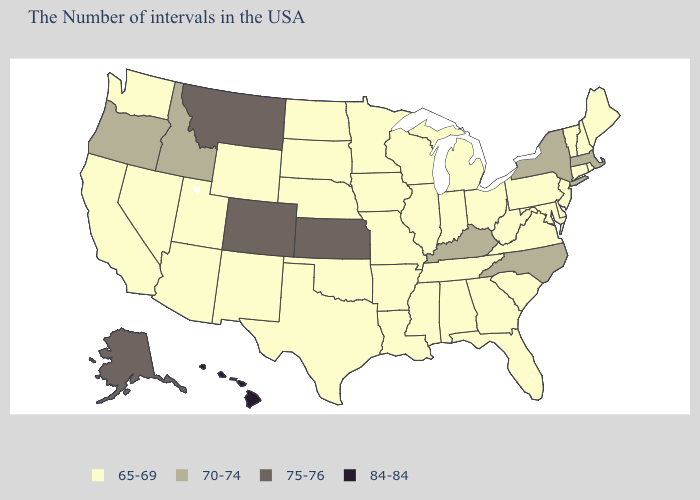What is the lowest value in states that border Illinois?
Quick response, please. 65-69. Among the states that border Utah , which have the highest value?
Give a very brief answer. Colorado. What is the lowest value in the USA?
Be succinct. 65-69. What is the value of Florida?
Answer briefly. 65-69. What is the lowest value in states that border Pennsylvania?
Write a very short answer. 65-69. Among the states that border Delaware , which have the highest value?
Answer briefly. New Jersey, Maryland, Pennsylvania. What is the lowest value in the USA?
Short answer required. 65-69. Name the states that have a value in the range 70-74?
Keep it brief. Massachusetts, New York, North Carolina, Kentucky, Idaho, Oregon. Name the states that have a value in the range 75-76?
Answer briefly. Kansas, Colorado, Montana, Alaska. Does Ohio have the highest value in the USA?
Quick response, please. No. What is the lowest value in the USA?
Give a very brief answer. 65-69. What is the value of New Jersey?
Give a very brief answer. 65-69. What is the lowest value in the USA?
Quick response, please. 65-69. What is the lowest value in the Northeast?
Answer briefly. 65-69. 